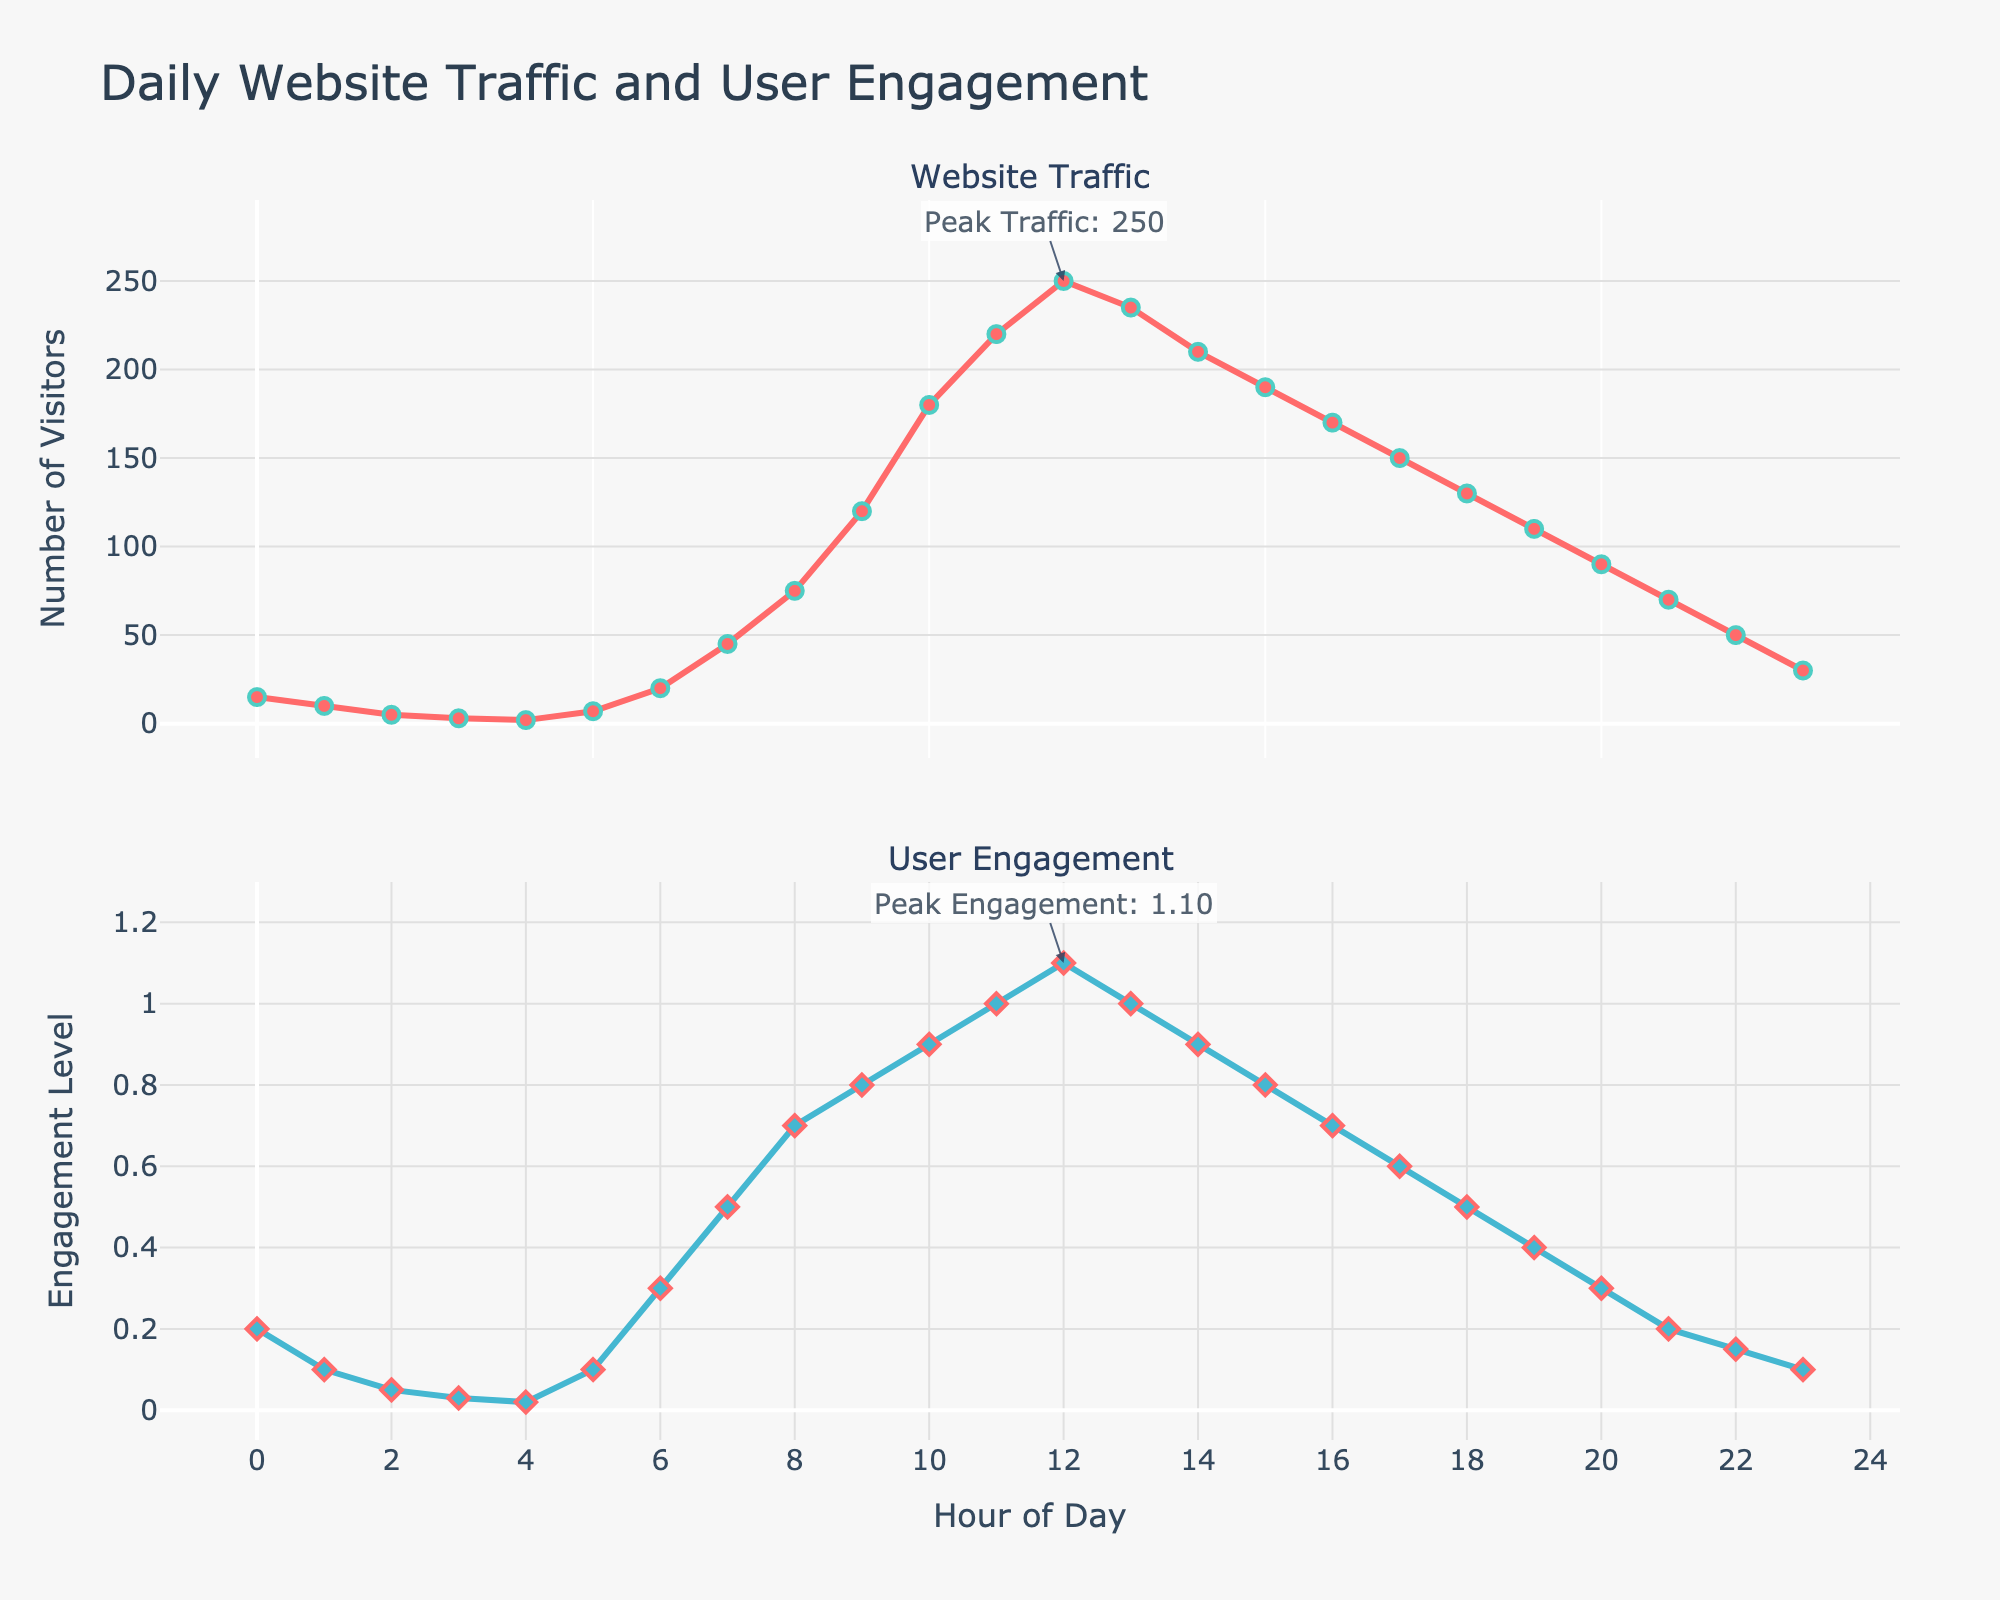What is the title of the plot? The title is displayed at the top of the figure and reads "Daily Website Traffic and User Engagement"
Answer: Daily Website Traffic and User Engagement At what hour does the website see the highest traffic? By looking at the "Website Traffic" subplot, the highest traffic is indicated by an annotation pointing to the peak value. This occurs at hour 12
Answer: 12 Which hour experiences the lowest engagement level? In the "User Engagement" subplot, the lowest value on the y-axis occurs at hour 4, as indicated by the lowest point on the graph
Answer: 4 How many data points are plotted in each subplot? There are hourly data points plotted from hour 0 to hour 23, so there are a total of 24 data points in each subplot
Answer: 24 Compare the traffic at 9 AM and 9 PM. Which is higher? At 9 AM (hour 9), the traffic is 120, and at 9 PM (hour 21), the traffic is 70, so the traffic is higher at 9 AM
Answer: 9 AM What is the engagement level at the peak traffic hour? The peak traffic hour is 12, and the corresponding engagement level can be found by looking at the "User Engagement" subplot at hour 12, which is 1.1
Answer: 1.1 What is the average engagement level between 6 AM and 6 PM? Calculate the average engagement level for hours 6 through 18: (0.3 + 0.5 + 0.7 + 0.8 + 0.9 + 1.0 + 1.1 + 1.0 + 0.9 + 0.8 + 0.7 + 0.6 + 0.5) / 13 = 8.8 / 13 ≈ 0.68
Answer: 0.68 How much does traffic decrease from the peak hour to 8 PM? The peak traffic is 250 at hour 12, and at 8 PM (hour 20), the traffic is 90. The decrease is 250 - 90 = 160
Answer: 160 What time range shows a steady decrease in traffic without any increase? The "Website Traffic" subplot shows a steady decrease from hour 12 to hour 4 without any increase in between
Answer: 12 PM to 4 AM 